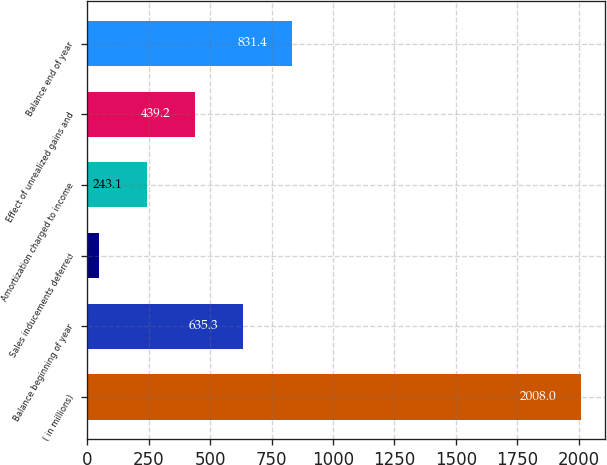<chart> <loc_0><loc_0><loc_500><loc_500><bar_chart><fcel>( in millions)<fcel>Balance beginning of year<fcel>Sales inducements deferred<fcel>Amortization charged to income<fcel>Effect of unrealized gains and<fcel>Balance end of year<nl><fcel>2008<fcel>635.3<fcel>47<fcel>243.1<fcel>439.2<fcel>831.4<nl></chart> 